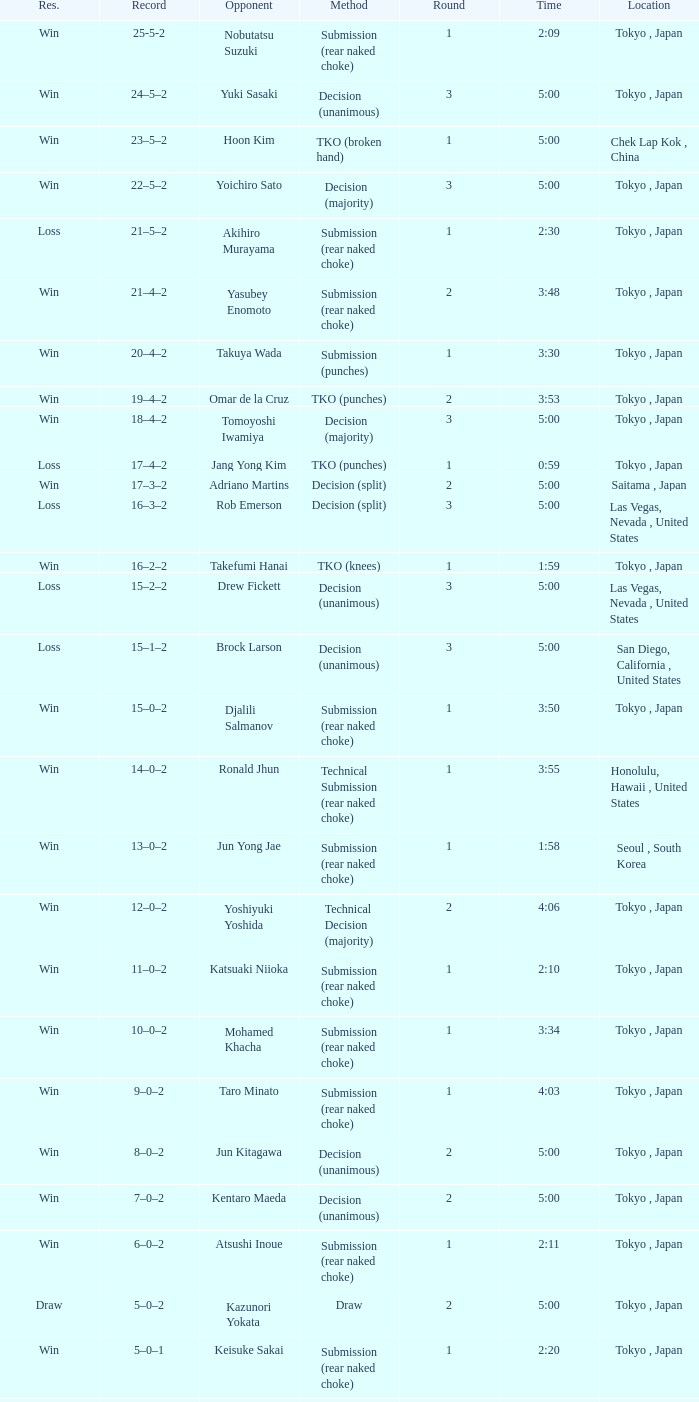What method had Adriano Martins as an opponent and a time of 5:00? Decision (split). 